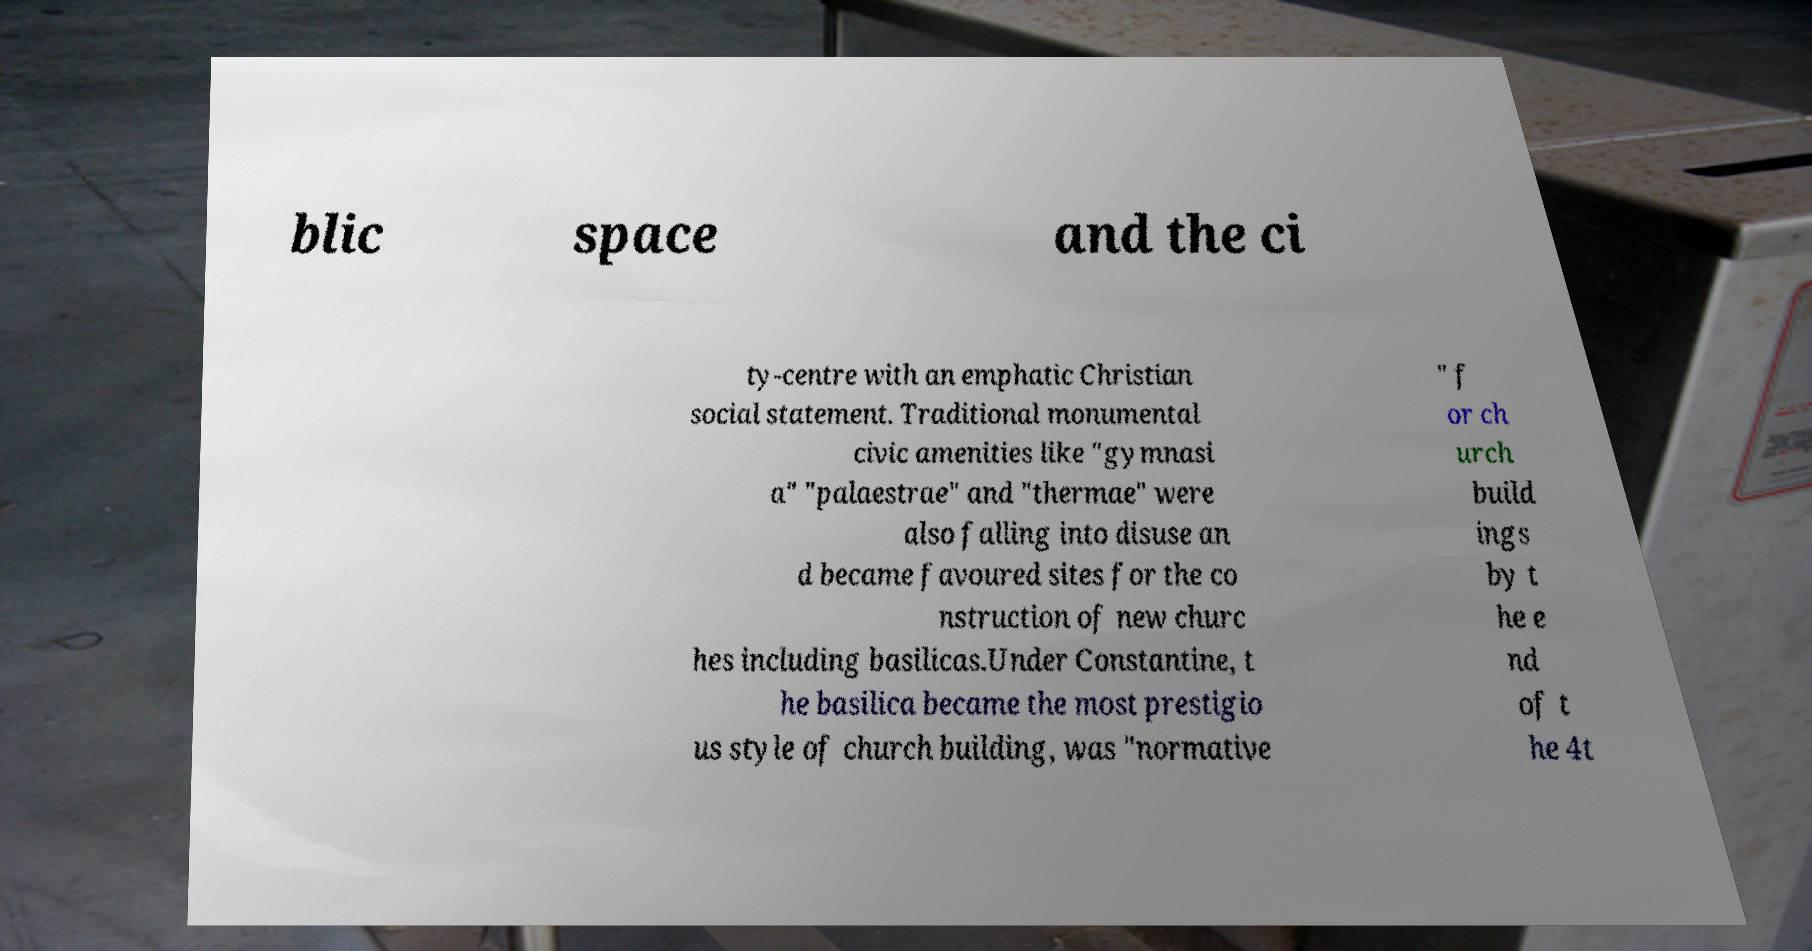Can you read and provide the text displayed in the image?This photo seems to have some interesting text. Can you extract and type it out for me? blic space and the ci ty-centre with an emphatic Christian social statement. Traditional monumental civic amenities like "gymnasi a" "palaestrae" and "thermae" were also falling into disuse an d became favoured sites for the co nstruction of new churc hes including basilicas.Under Constantine, t he basilica became the most prestigio us style of church building, was "normative " f or ch urch build ings by t he e nd of t he 4t 